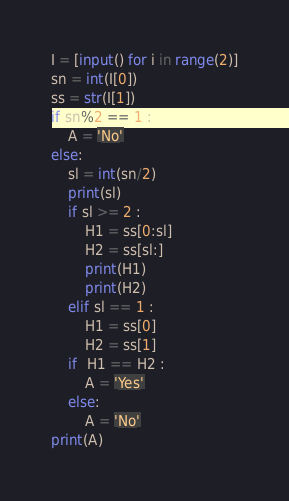<code> <loc_0><loc_0><loc_500><loc_500><_Python_>I = [input() for i in range(2)]
sn = int(I[0])
ss = str(I[1])
if sn%2 == 1 :
    A = 'No' 
else:
    sl = int(sn/2) 
    print(sl)
    if sl >= 2 : 
        H1 = ss[0:sl]
        H2 = ss[sl:]
        print(H1)
        print(H2)
    elif sl == 1 :
        H1 = ss[0]
        H2 = ss[1]
    if  H1 == H2 :
        A = 'Yes'
    else:
        A = 'No'
print(A)</code> 